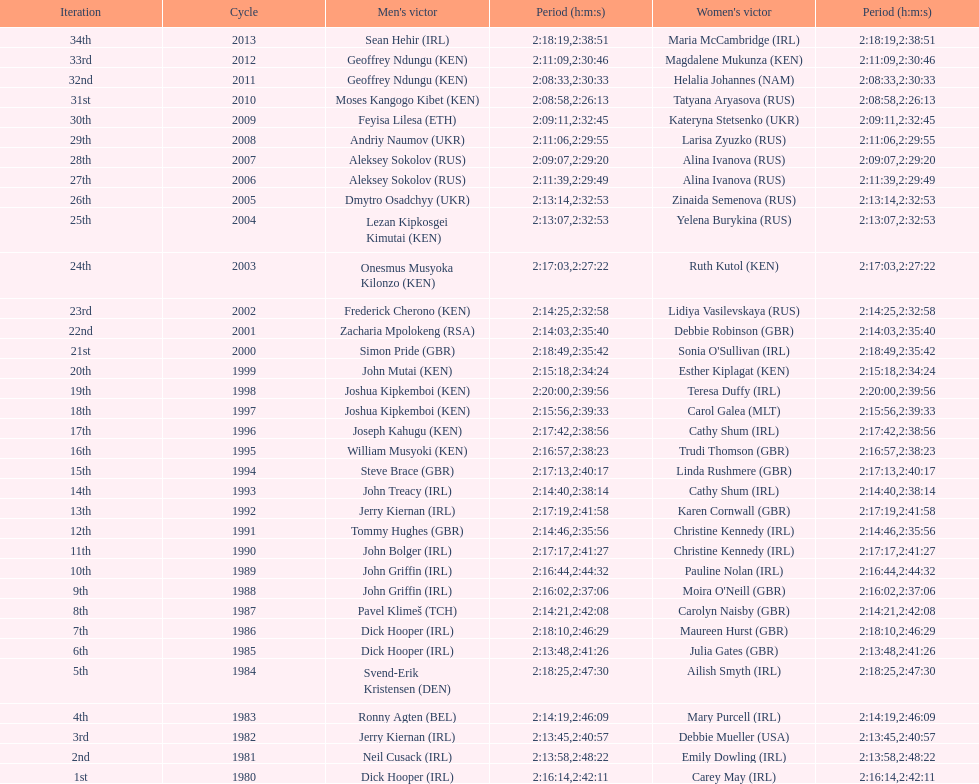In 2009, which competitor finished faster - the male or the female? Male. 